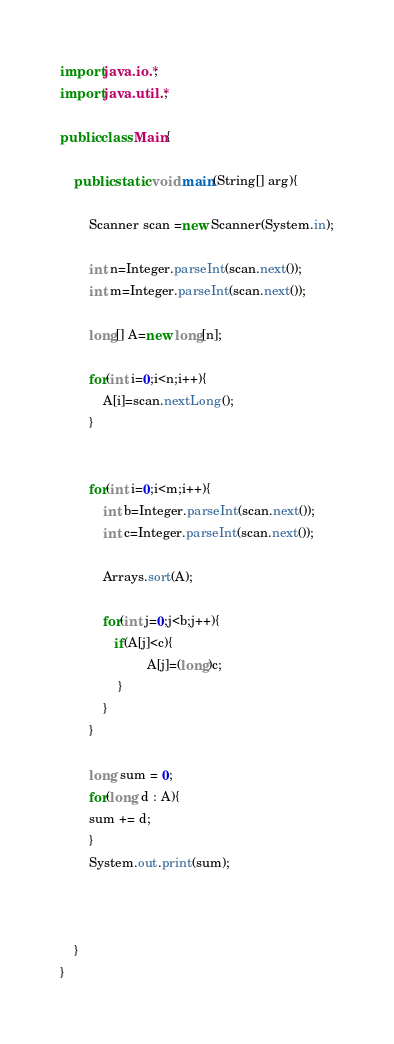Convert code to text. <code><loc_0><loc_0><loc_500><loc_500><_Java_>import java.io.*;
import java.util.*;

public class Main{
    
    public static void main(String[] arg){

        Scanner scan =new Scanner(System.in);

        int n=Integer.parseInt(scan.next());
        int m=Integer.parseInt(scan.next());

        long[] A=new long[n];

        for(int i=0;i<n;i++){
            A[i]=scan.nextLong();
        }


        for(int i=0;i<m;i++){
            int b=Integer.parseInt(scan.next());
            int c=Integer.parseInt(scan.next());
            
            Arrays.sort(A);

            for(int j=0;j<b;j++){
               if(A[j]<c){
                        A[j]=(long)c;
                }
            }
        }

        long sum = 0;
        for(long d : A){
        sum += d;
        }
        System.out.print(sum);
        
        
     
    }
}</code> 